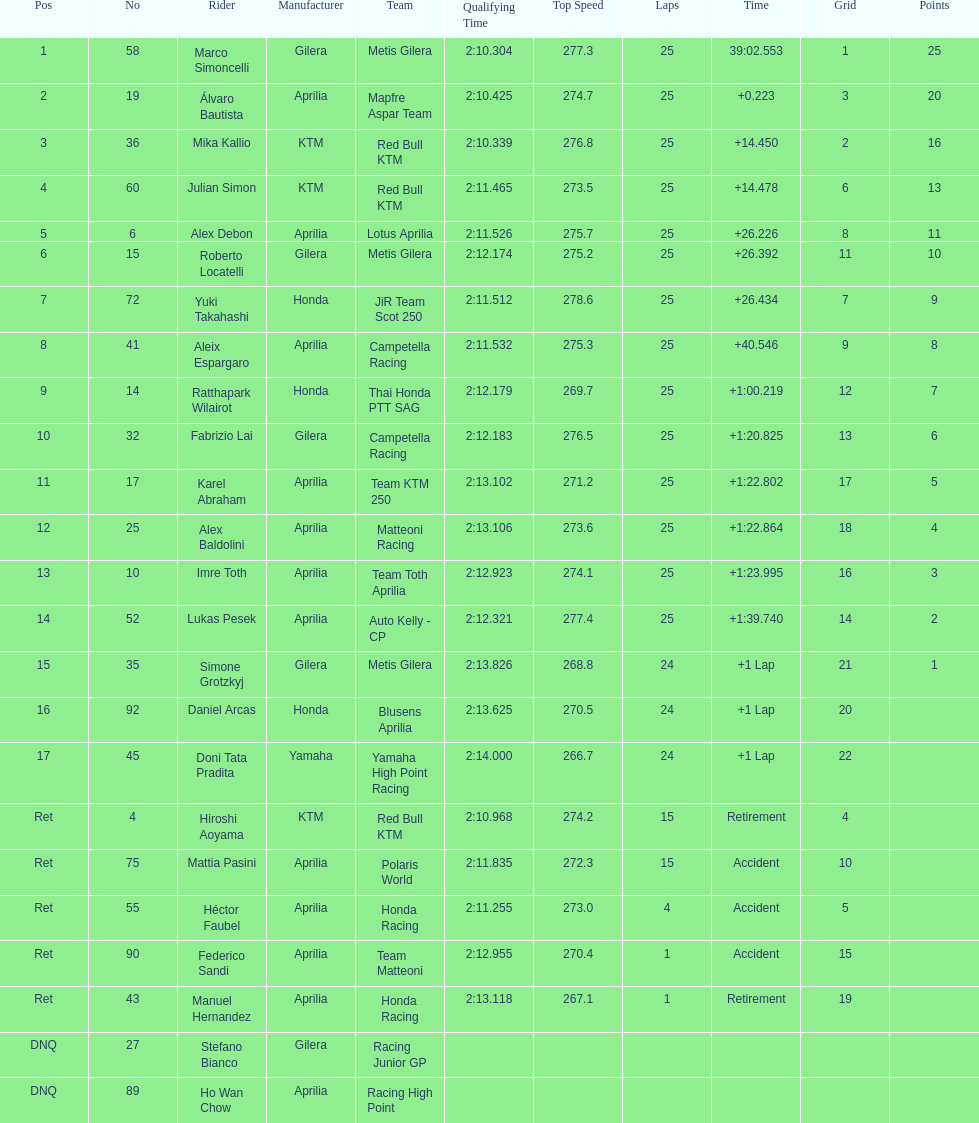How many laps in total has imre toth executed? 25. 